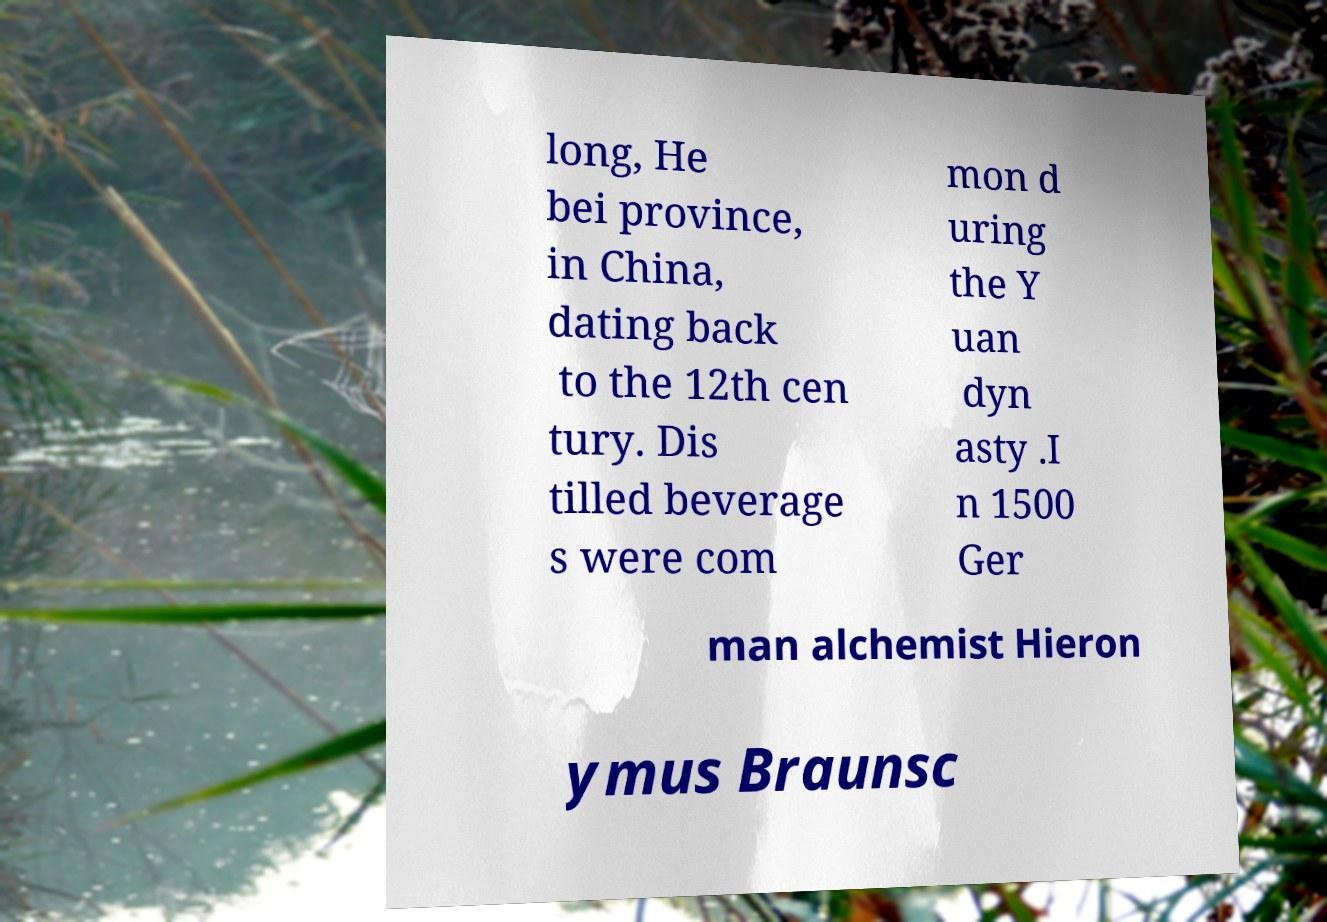There's text embedded in this image that I need extracted. Can you transcribe it verbatim? long, He bei province, in China, dating back to the 12th cen tury. Dis tilled beverage s were com mon d uring the Y uan dyn asty .I n 1500 Ger man alchemist Hieron ymus Braunsc 